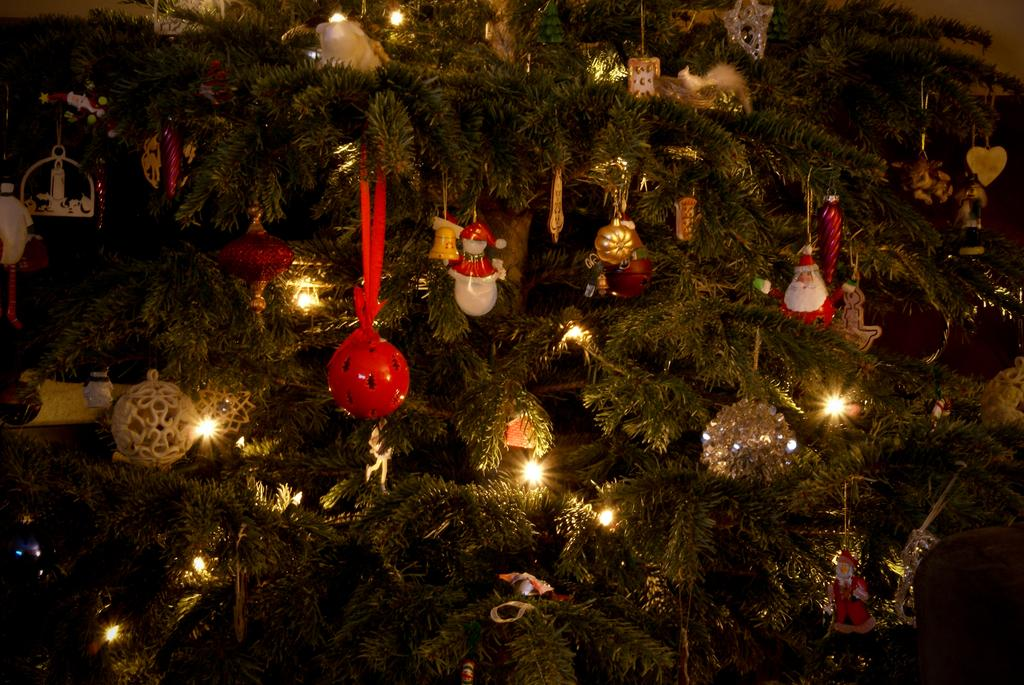What is the main object in the image? There is a Christmas tree in the image. What type of decorations are on the Christmas tree? The Christmas tree has decorative items like balls, decorative lights, and decorative hangings. How much debt does the boy owe in the image? There is no boy or mention of debt in the image; it only features a Christmas tree with decorations. 